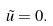<formula> <loc_0><loc_0><loc_500><loc_500>\tilde { u } = 0 .</formula> 